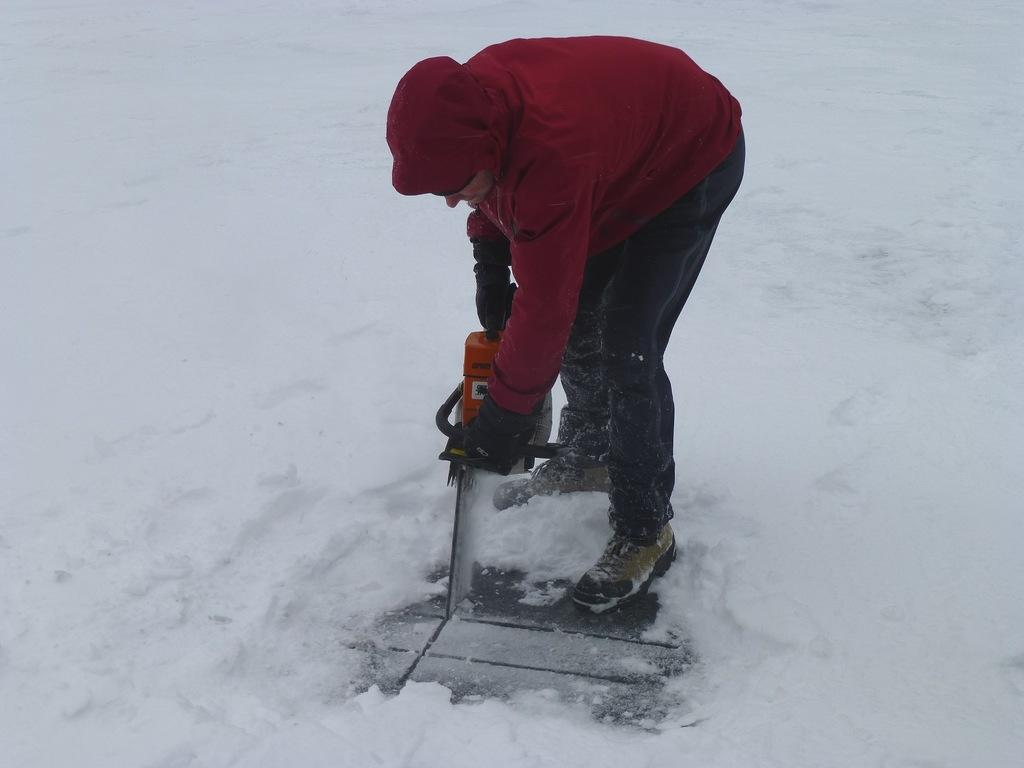What is the main subject in the center of the image? There is a person in the center of the image. What is the person holding in their hands? The person is holding something in their hands, but the specific object is not mentioned in the facts. What is the ground made of at the bottom of the image? There is snow at the bottom of the image. Can you describe any path or walkway in the image? Yes, there is a walkway in the image. What type of argument is taking place between the pigs in the image? There are no pigs present in the image, so no argument can be observed. How many chickens can be seen interacting with the person in the image? There are no chickens present in the image, so no interaction can be observed. 